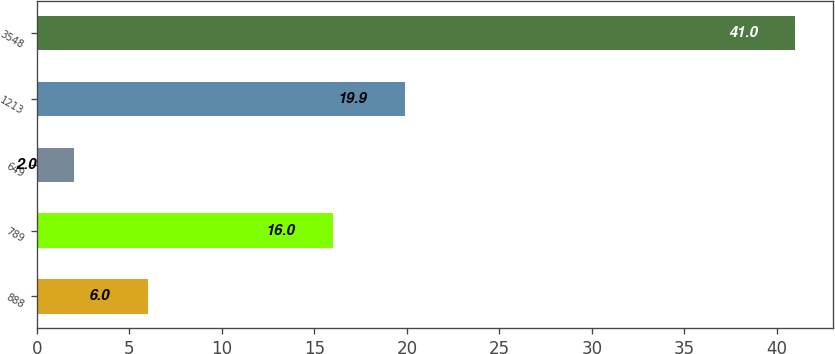Convert chart to OTSL. <chart><loc_0><loc_0><loc_500><loc_500><bar_chart><fcel>888<fcel>789<fcel>649<fcel>1213<fcel>3548<nl><fcel>6<fcel>16<fcel>2<fcel>19.9<fcel>41<nl></chart> 